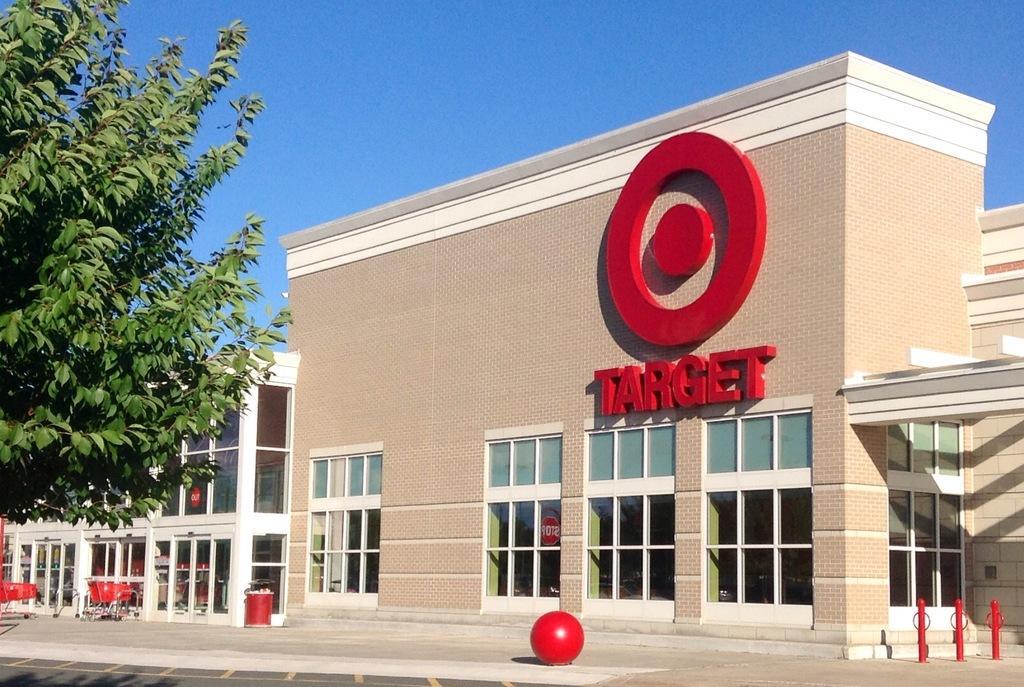Please provide a concise description of this image. In this picture we can see few buildings, in front of the buildings we can find few metal rods, carts and a tree. 